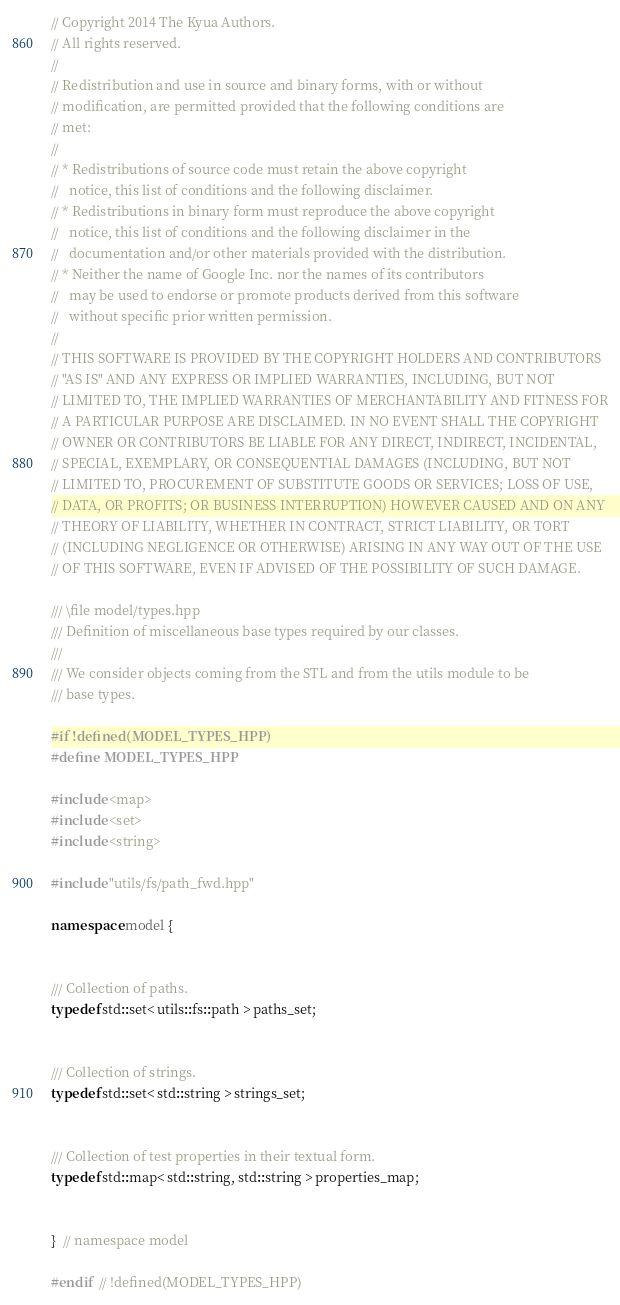<code> <loc_0><loc_0><loc_500><loc_500><_C++_>// Copyright 2014 The Kyua Authors.
// All rights reserved.
//
// Redistribution and use in source and binary forms, with or without
// modification, are permitted provided that the following conditions are
// met:
//
// * Redistributions of source code must retain the above copyright
//   notice, this list of conditions and the following disclaimer.
// * Redistributions in binary form must reproduce the above copyright
//   notice, this list of conditions and the following disclaimer in the
//   documentation and/or other materials provided with the distribution.
// * Neither the name of Google Inc. nor the names of its contributors
//   may be used to endorse or promote products derived from this software
//   without specific prior written permission.
//
// THIS SOFTWARE IS PROVIDED BY THE COPYRIGHT HOLDERS AND CONTRIBUTORS
// "AS IS" AND ANY EXPRESS OR IMPLIED WARRANTIES, INCLUDING, BUT NOT
// LIMITED TO, THE IMPLIED WARRANTIES OF MERCHANTABILITY AND FITNESS FOR
// A PARTICULAR PURPOSE ARE DISCLAIMED. IN NO EVENT SHALL THE COPYRIGHT
// OWNER OR CONTRIBUTORS BE LIABLE FOR ANY DIRECT, INDIRECT, INCIDENTAL,
// SPECIAL, EXEMPLARY, OR CONSEQUENTIAL DAMAGES (INCLUDING, BUT NOT
// LIMITED TO, PROCUREMENT OF SUBSTITUTE GOODS OR SERVICES; LOSS OF USE,
// DATA, OR PROFITS; OR BUSINESS INTERRUPTION) HOWEVER CAUSED AND ON ANY
// THEORY OF LIABILITY, WHETHER IN CONTRACT, STRICT LIABILITY, OR TORT
// (INCLUDING NEGLIGENCE OR OTHERWISE) ARISING IN ANY WAY OUT OF THE USE
// OF THIS SOFTWARE, EVEN IF ADVISED OF THE POSSIBILITY OF SUCH DAMAGE.

/// \file model/types.hpp
/// Definition of miscellaneous base types required by our classes.
///
/// We consider objects coming from the STL and from the utils module to be
/// base types.

#if !defined(MODEL_TYPES_HPP)
#define MODEL_TYPES_HPP

#include <map>
#include <set>
#include <string>

#include "utils/fs/path_fwd.hpp"

namespace model {


/// Collection of paths.
typedef std::set< utils::fs::path > paths_set;


/// Collection of strings.
typedef std::set< std::string > strings_set;


/// Collection of test properties in their textual form.
typedef std::map< std::string, std::string > properties_map;


}  // namespace model

#endif  // !defined(MODEL_TYPES_HPP)
</code> 